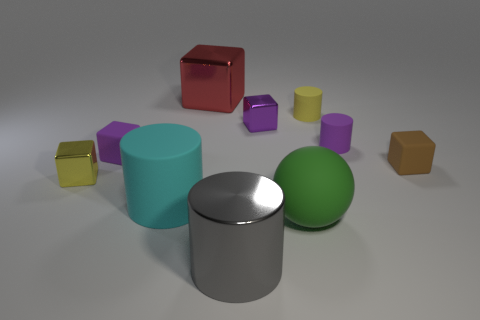Subtract all green cylinders. How many purple blocks are left? 2 Subtract all red cubes. How many cubes are left? 4 Subtract all big gray cylinders. How many cylinders are left? 3 Subtract 1 cylinders. How many cylinders are left? 3 Subtract all blue cylinders. Subtract all yellow spheres. How many cylinders are left? 4 Subtract all cylinders. How many objects are left? 6 Subtract 0 brown balls. How many objects are left? 10 Subtract all yellow metal things. Subtract all green shiny objects. How many objects are left? 9 Add 4 tiny purple rubber things. How many tiny purple rubber things are left? 6 Add 8 shiny spheres. How many shiny spheres exist? 8 